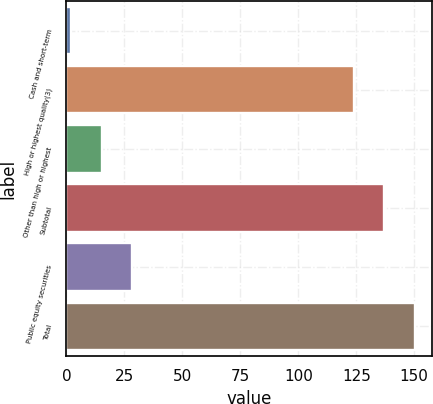Convert chart to OTSL. <chart><loc_0><loc_0><loc_500><loc_500><bar_chart><fcel>Cash and short-term<fcel>High or highest quality(3)<fcel>Other than high or highest<fcel>Subtotal<fcel>Public equity securities<fcel>Total<nl><fcel>2.1<fcel>123.9<fcel>15.22<fcel>137.02<fcel>28.34<fcel>150.14<nl></chart> 